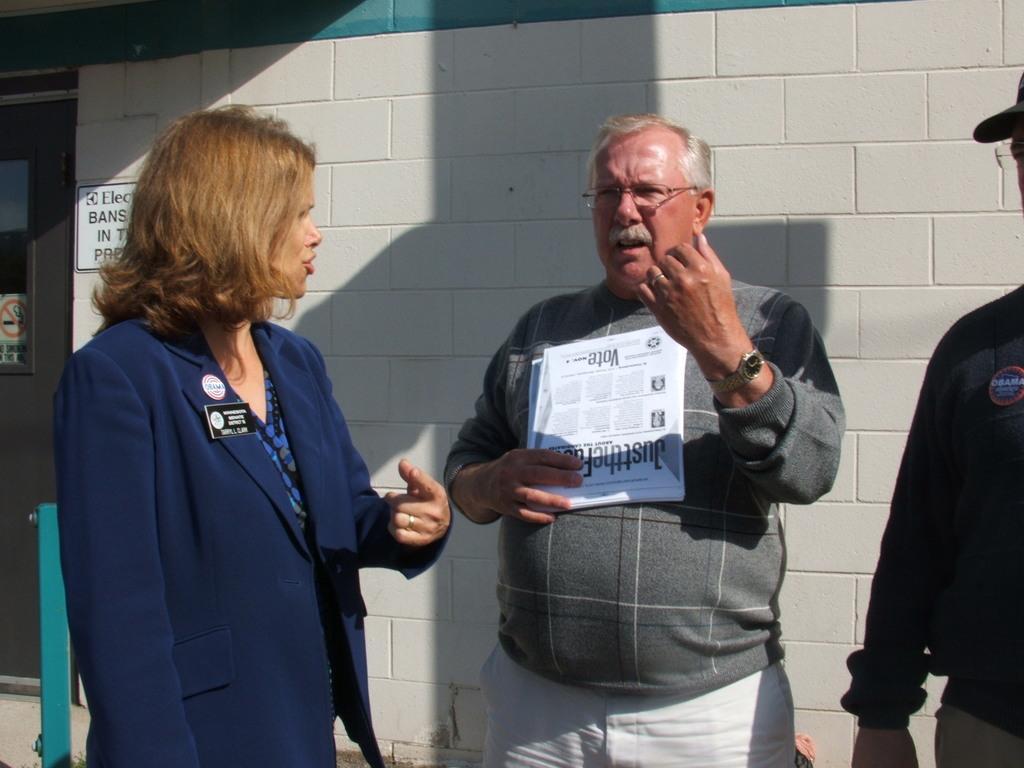How would you summarize this image in a sentence or two? In the picture we can see a man and a woman standing and talking to each other and beside we can see a person is standing and in the background, we can see the wall with a part of the door to it. 